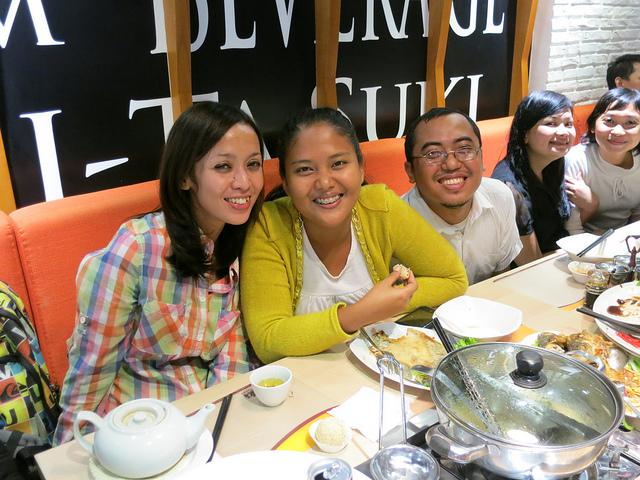Are these people sitting in their home dining room?
Quick response, please. No. Are these people African?
Short answer required. No. How many metal kitchenware are there?
Concise answer only. 1. 